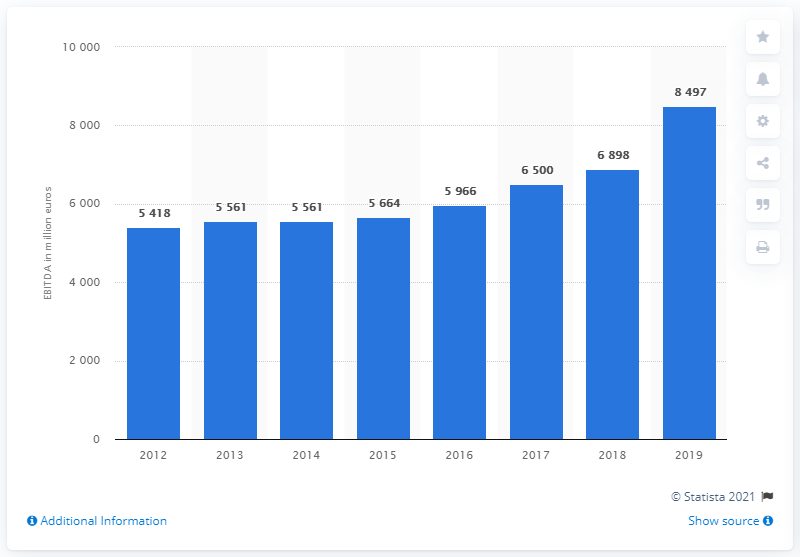Draw attention to some important aspects in this diagram. The French concessions and construction company generated an EBITDA of 8,497 in the fiscal year of 2019. In 2012, EBITDA was first reported for Vinci. In the year 2019, Vinci's EBITDA (earnings before interest, taxes, depreciation, and amortization) came to an end. 